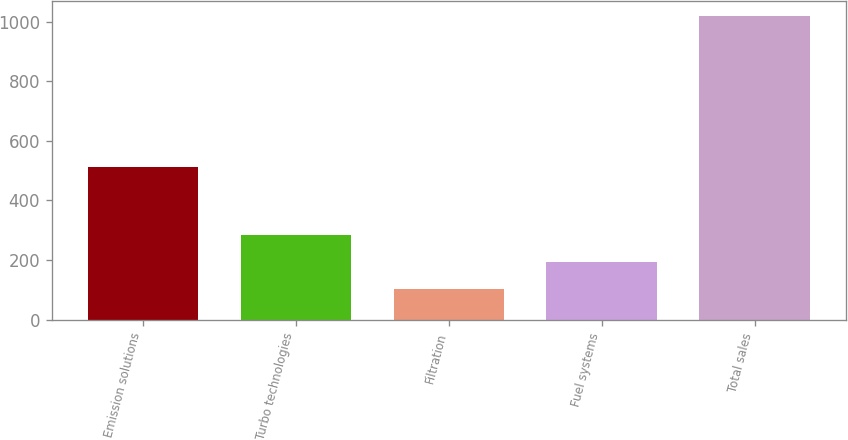Convert chart to OTSL. <chart><loc_0><loc_0><loc_500><loc_500><bar_chart><fcel>Emission solutions<fcel>Turbo technologies<fcel>Filtration<fcel>Fuel systems<fcel>Total sales<nl><fcel>512<fcel>285<fcel>102<fcel>193.5<fcel>1017<nl></chart> 